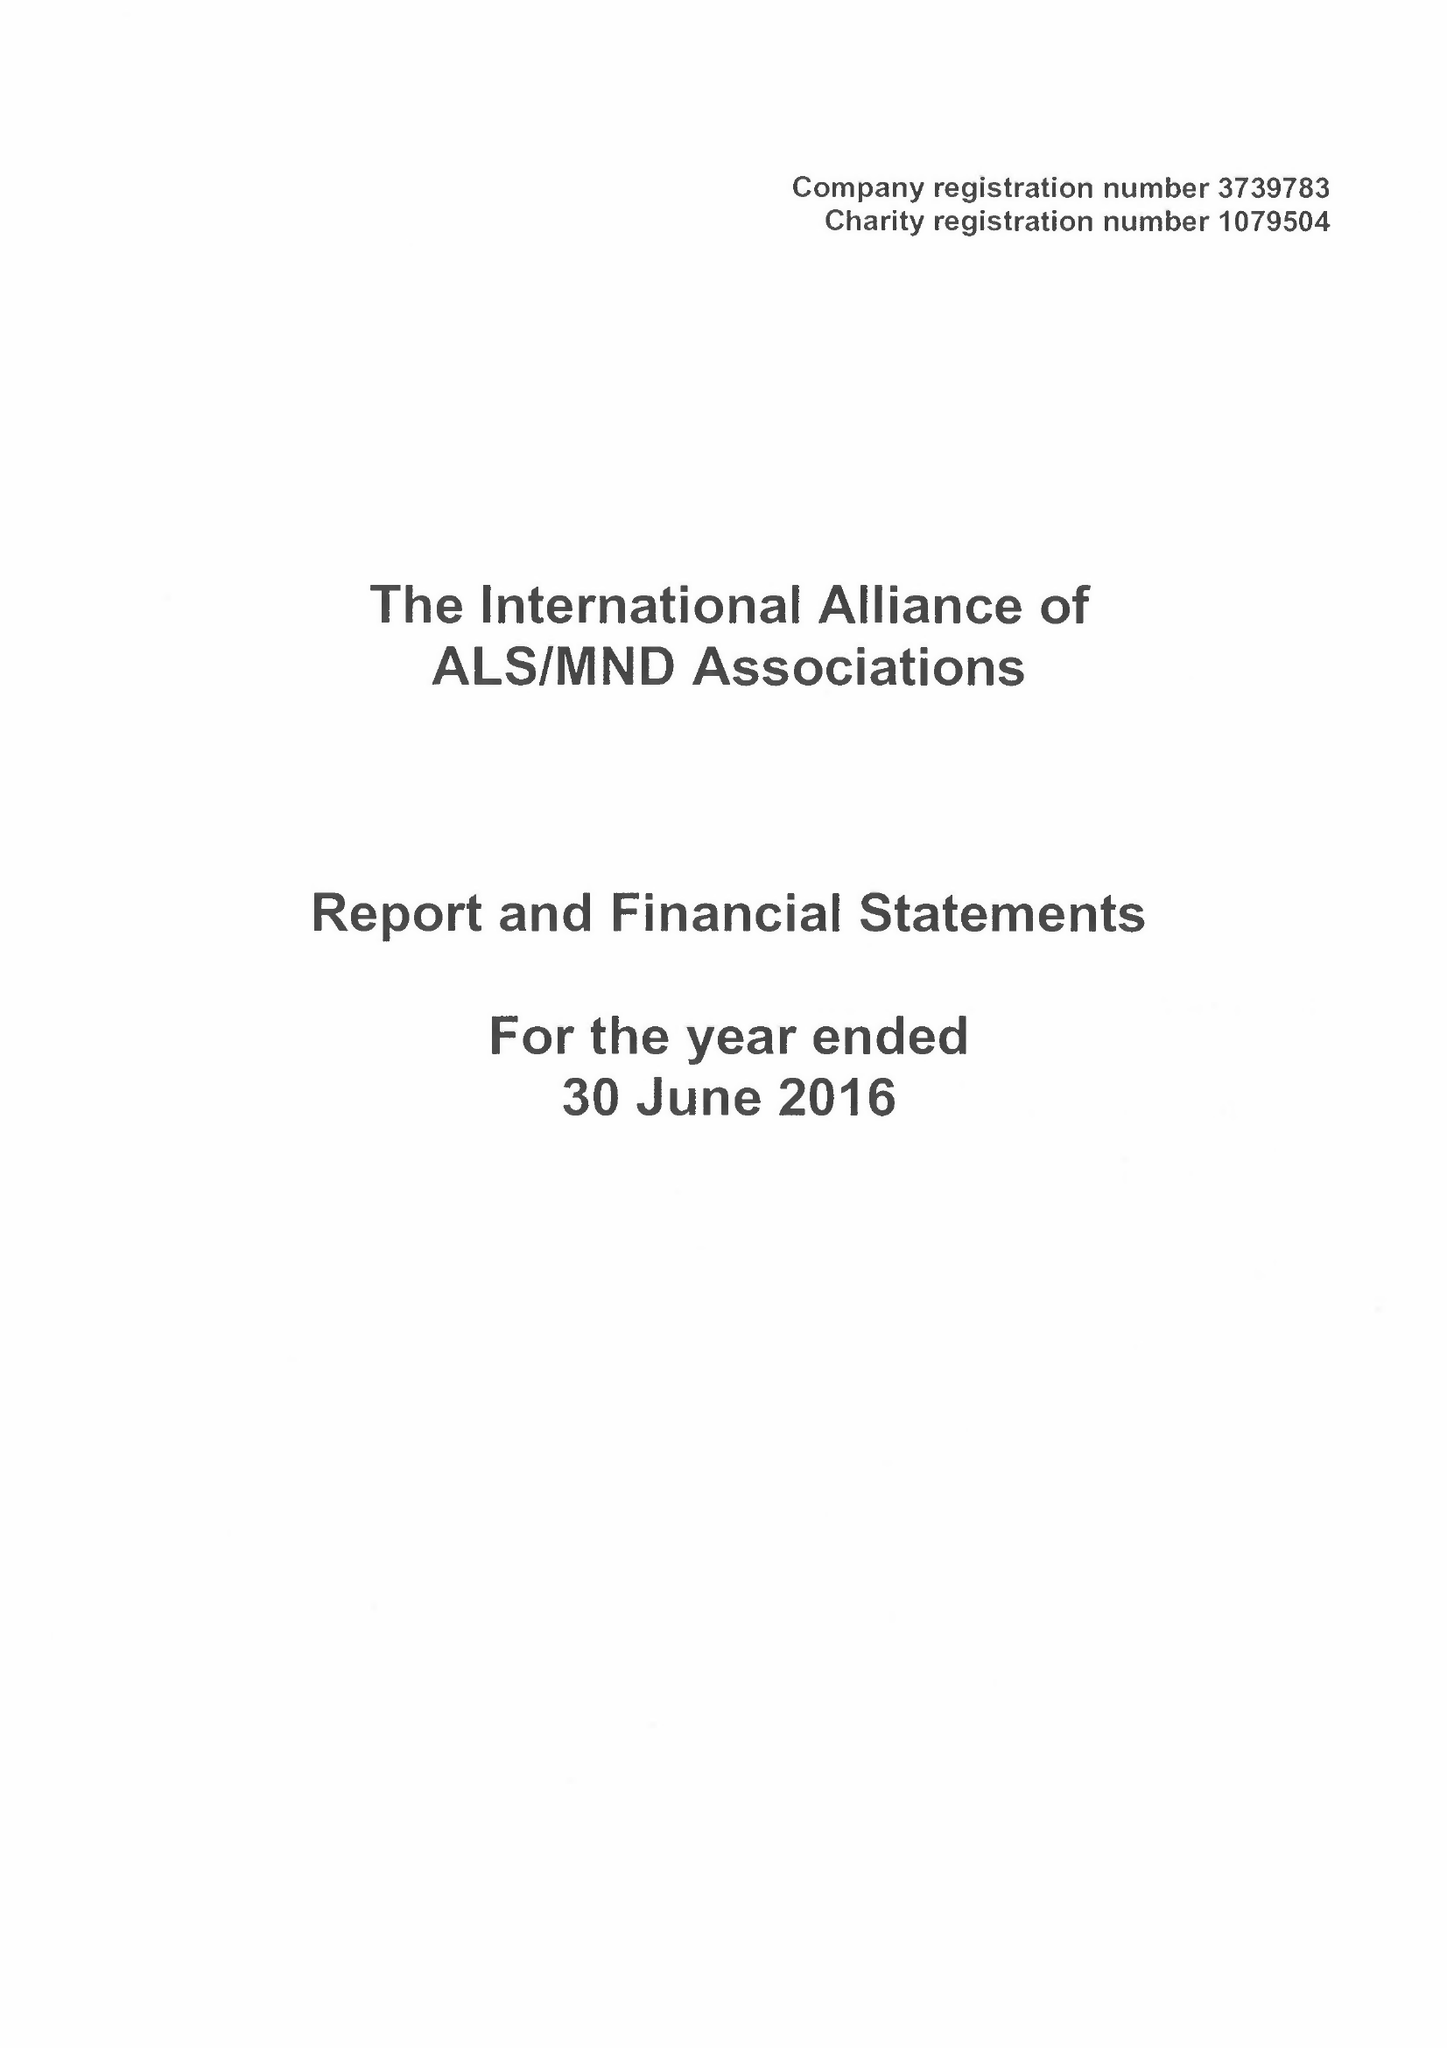What is the value for the spending_annually_in_british_pounds?
Answer the question using a single word or phrase. 135224.00 